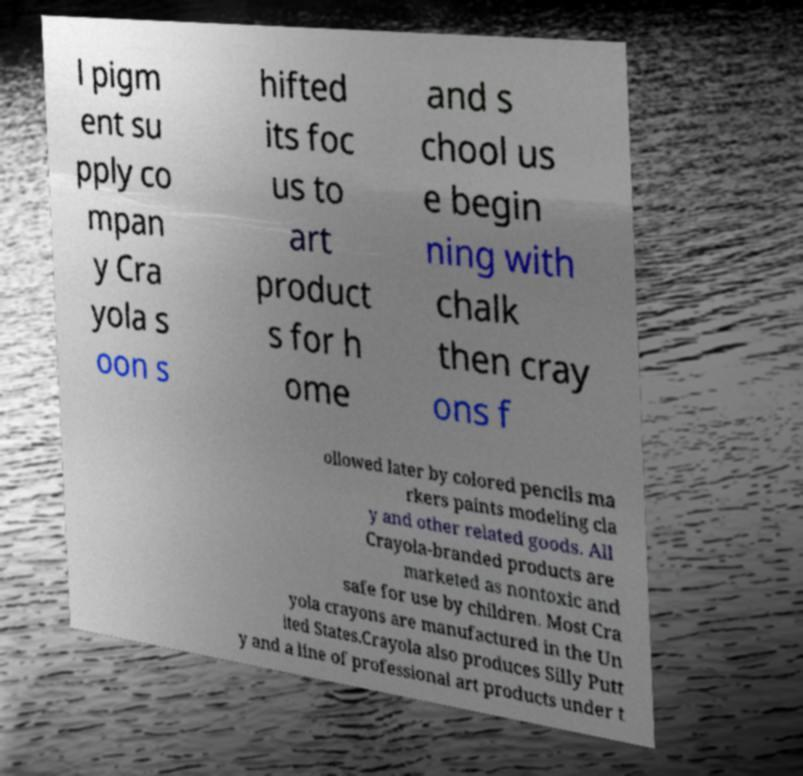There's text embedded in this image that I need extracted. Can you transcribe it verbatim? l pigm ent su pply co mpan y Cra yola s oon s hifted its foc us to art product s for h ome and s chool us e begin ning with chalk then cray ons f ollowed later by colored pencils ma rkers paints modeling cla y and other related goods. All Crayola-branded products are marketed as nontoxic and safe for use by children. Most Cra yola crayons are manufactured in the Un ited States.Crayola also produces Silly Putt y and a line of professional art products under t 